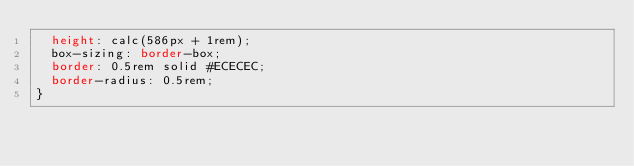Convert code to text. <code><loc_0><loc_0><loc_500><loc_500><_CSS_>  height: calc(586px + 1rem);
  box-sizing: border-box;
  border: 0.5rem solid #ECECEC;
  border-radius: 0.5rem;
}</code> 